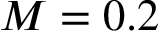Convert formula to latex. <formula><loc_0><loc_0><loc_500><loc_500>M = 0 . 2</formula> 